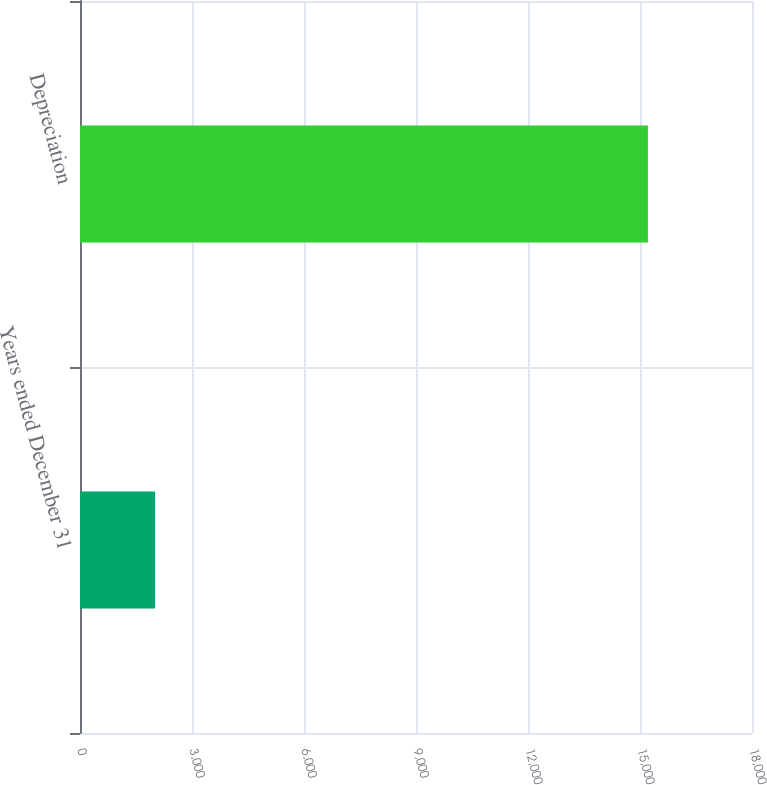Convert chart to OTSL. <chart><loc_0><loc_0><loc_500><loc_500><bar_chart><fcel>Years ended December 31<fcel>Depreciation<nl><fcel>2012<fcel>15212<nl></chart> 